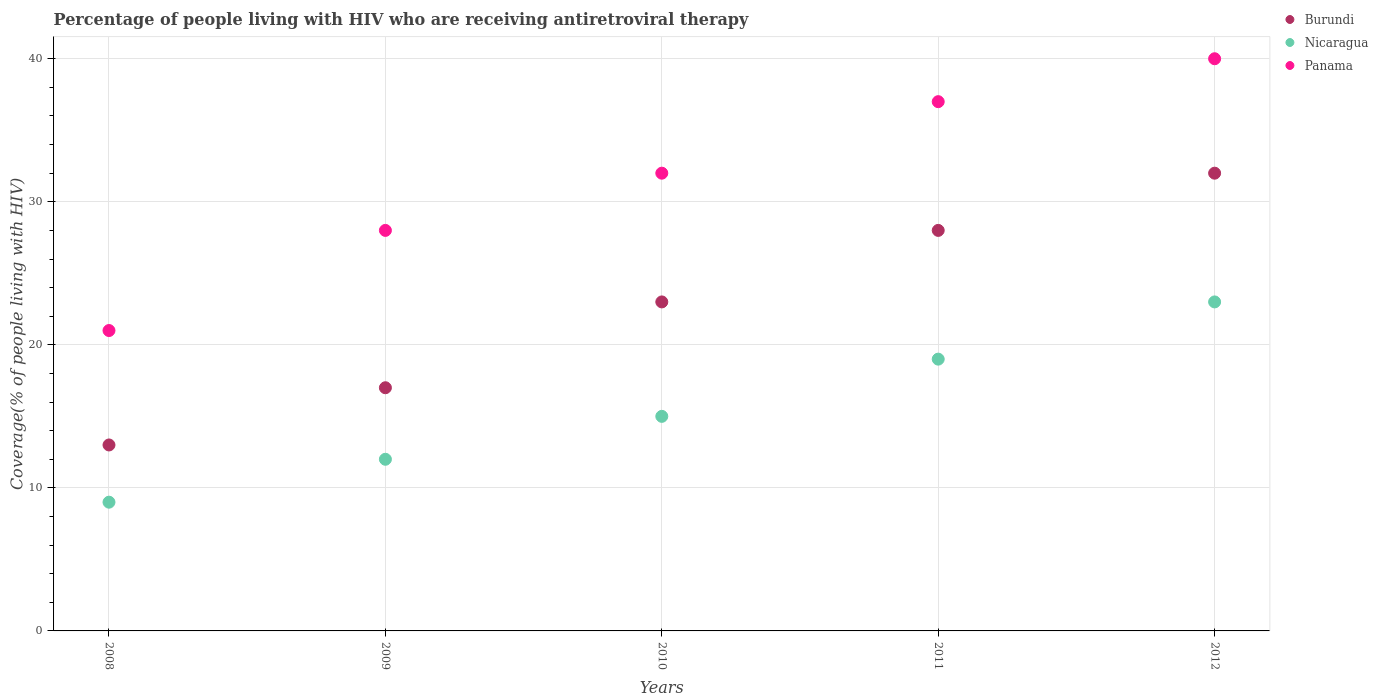What is the percentage of the HIV infected people who are receiving antiretroviral therapy in Nicaragua in 2011?
Provide a succinct answer. 19. Across all years, what is the maximum percentage of the HIV infected people who are receiving antiretroviral therapy in Burundi?
Offer a terse response. 32. Across all years, what is the minimum percentage of the HIV infected people who are receiving antiretroviral therapy in Nicaragua?
Offer a terse response. 9. In which year was the percentage of the HIV infected people who are receiving antiretroviral therapy in Panama maximum?
Provide a succinct answer. 2012. What is the total percentage of the HIV infected people who are receiving antiretroviral therapy in Burundi in the graph?
Your answer should be compact. 113. What is the difference between the percentage of the HIV infected people who are receiving antiretroviral therapy in Nicaragua in 2010 and that in 2012?
Offer a very short reply. -8. What is the difference between the percentage of the HIV infected people who are receiving antiretroviral therapy in Nicaragua in 2011 and the percentage of the HIV infected people who are receiving antiretroviral therapy in Panama in 2010?
Your response must be concise. -13. What is the average percentage of the HIV infected people who are receiving antiretroviral therapy in Nicaragua per year?
Ensure brevity in your answer.  15.6. In the year 2008, what is the difference between the percentage of the HIV infected people who are receiving antiretroviral therapy in Nicaragua and percentage of the HIV infected people who are receiving antiretroviral therapy in Panama?
Your response must be concise. -12. In how many years, is the percentage of the HIV infected people who are receiving antiretroviral therapy in Nicaragua greater than 36 %?
Your response must be concise. 0. What is the ratio of the percentage of the HIV infected people who are receiving antiretroviral therapy in Burundi in 2008 to that in 2011?
Your answer should be compact. 0.46. Is the difference between the percentage of the HIV infected people who are receiving antiretroviral therapy in Nicaragua in 2010 and 2011 greater than the difference between the percentage of the HIV infected people who are receiving antiretroviral therapy in Panama in 2010 and 2011?
Your response must be concise. Yes. What is the difference between the highest and the lowest percentage of the HIV infected people who are receiving antiretroviral therapy in Panama?
Provide a succinct answer. 19. In how many years, is the percentage of the HIV infected people who are receiving antiretroviral therapy in Nicaragua greater than the average percentage of the HIV infected people who are receiving antiretroviral therapy in Nicaragua taken over all years?
Your answer should be very brief. 2. Is the sum of the percentage of the HIV infected people who are receiving antiretroviral therapy in Panama in 2008 and 2010 greater than the maximum percentage of the HIV infected people who are receiving antiretroviral therapy in Nicaragua across all years?
Provide a short and direct response. Yes. Is it the case that in every year, the sum of the percentage of the HIV infected people who are receiving antiretroviral therapy in Burundi and percentage of the HIV infected people who are receiving antiretroviral therapy in Panama  is greater than the percentage of the HIV infected people who are receiving antiretroviral therapy in Nicaragua?
Offer a terse response. Yes. Does the percentage of the HIV infected people who are receiving antiretroviral therapy in Nicaragua monotonically increase over the years?
Give a very brief answer. Yes. How many dotlines are there?
Give a very brief answer. 3. How many years are there in the graph?
Keep it short and to the point. 5. Are the values on the major ticks of Y-axis written in scientific E-notation?
Offer a terse response. No. Where does the legend appear in the graph?
Give a very brief answer. Top right. How many legend labels are there?
Provide a succinct answer. 3. How are the legend labels stacked?
Keep it short and to the point. Vertical. What is the title of the graph?
Your response must be concise. Percentage of people living with HIV who are receiving antiretroviral therapy. Does "Bermuda" appear as one of the legend labels in the graph?
Provide a short and direct response. No. What is the label or title of the X-axis?
Give a very brief answer. Years. What is the label or title of the Y-axis?
Make the answer very short. Coverage(% of people living with HIV). What is the Coverage(% of people living with HIV) in Nicaragua in 2008?
Keep it short and to the point. 9. What is the Coverage(% of people living with HIV) in Panama in 2008?
Give a very brief answer. 21. What is the Coverage(% of people living with HIV) in Nicaragua in 2010?
Your answer should be compact. 15. What is the Coverage(% of people living with HIV) in Burundi in 2011?
Offer a very short reply. 28. What is the Coverage(% of people living with HIV) in Panama in 2011?
Your answer should be very brief. 37. What is the Coverage(% of people living with HIV) in Nicaragua in 2012?
Your response must be concise. 23. What is the Coverage(% of people living with HIV) in Panama in 2012?
Provide a short and direct response. 40. Across all years, what is the maximum Coverage(% of people living with HIV) in Nicaragua?
Ensure brevity in your answer.  23. Across all years, what is the minimum Coverage(% of people living with HIV) in Burundi?
Ensure brevity in your answer.  13. Across all years, what is the minimum Coverage(% of people living with HIV) of Nicaragua?
Provide a succinct answer. 9. Across all years, what is the minimum Coverage(% of people living with HIV) in Panama?
Offer a terse response. 21. What is the total Coverage(% of people living with HIV) in Burundi in the graph?
Offer a terse response. 113. What is the total Coverage(% of people living with HIV) of Nicaragua in the graph?
Your answer should be very brief. 78. What is the total Coverage(% of people living with HIV) of Panama in the graph?
Your response must be concise. 158. What is the difference between the Coverage(% of people living with HIV) in Burundi in 2008 and that in 2009?
Keep it short and to the point. -4. What is the difference between the Coverage(% of people living with HIV) in Nicaragua in 2008 and that in 2009?
Ensure brevity in your answer.  -3. What is the difference between the Coverage(% of people living with HIV) in Panama in 2008 and that in 2010?
Offer a terse response. -11. What is the difference between the Coverage(% of people living with HIV) of Nicaragua in 2008 and that in 2011?
Ensure brevity in your answer.  -10. What is the difference between the Coverage(% of people living with HIV) of Nicaragua in 2008 and that in 2012?
Your response must be concise. -14. What is the difference between the Coverage(% of people living with HIV) in Burundi in 2009 and that in 2010?
Your answer should be compact. -6. What is the difference between the Coverage(% of people living with HIV) of Burundi in 2009 and that in 2011?
Ensure brevity in your answer.  -11. What is the difference between the Coverage(% of people living with HIV) of Panama in 2009 and that in 2011?
Provide a short and direct response. -9. What is the difference between the Coverage(% of people living with HIV) of Nicaragua in 2009 and that in 2012?
Give a very brief answer. -11. What is the difference between the Coverage(% of people living with HIV) in Burundi in 2010 and that in 2011?
Your answer should be compact. -5. What is the difference between the Coverage(% of people living with HIV) of Burundi in 2010 and that in 2012?
Your answer should be compact. -9. What is the difference between the Coverage(% of people living with HIV) of Panama in 2010 and that in 2012?
Give a very brief answer. -8. What is the difference between the Coverage(% of people living with HIV) of Nicaragua in 2011 and that in 2012?
Provide a succinct answer. -4. What is the difference between the Coverage(% of people living with HIV) of Burundi in 2008 and the Coverage(% of people living with HIV) of Nicaragua in 2009?
Your answer should be compact. 1. What is the difference between the Coverage(% of people living with HIV) in Burundi in 2008 and the Coverage(% of people living with HIV) in Panama in 2009?
Your response must be concise. -15. What is the difference between the Coverage(% of people living with HIV) of Burundi in 2008 and the Coverage(% of people living with HIV) of Nicaragua in 2010?
Keep it short and to the point. -2. What is the difference between the Coverage(% of people living with HIV) of Burundi in 2008 and the Coverage(% of people living with HIV) of Panama in 2010?
Offer a very short reply. -19. What is the difference between the Coverage(% of people living with HIV) of Burundi in 2008 and the Coverage(% of people living with HIV) of Nicaragua in 2012?
Provide a short and direct response. -10. What is the difference between the Coverage(% of people living with HIV) of Nicaragua in 2008 and the Coverage(% of people living with HIV) of Panama in 2012?
Your answer should be very brief. -31. What is the difference between the Coverage(% of people living with HIV) in Burundi in 2009 and the Coverage(% of people living with HIV) in Panama in 2010?
Your answer should be compact. -15. What is the difference between the Coverage(% of people living with HIV) in Burundi in 2010 and the Coverage(% of people living with HIV) in Nicaragua in 2011?
Provide a succinct answer. 4. What is the difference between the Coverage(% of people living with HIV) in Nicaragua in 2010 and the Coverage(% of people living with HIV) in Panama in 2011?
Your answer should be very brief. -22. What is the difference between the Coverage(% of people living with HIV) in Burundi in 2010 and the Coverage(% of people living with HIV) in Panama in 2012?
Provide a succinct answer. -17. What is the difference between the Coverage(% of people living with HIV) in Burundi in 2011 and the Coverage(% of people living with HIV) in Panama in 2012?
Provide a succinct answer. -12. What is the average Coverage(% of people living with HIV) of Burundi per year?
Offer a very short reply. 22.6. What is the average Coverage(% of people living with HIV) in Nicaragua per year?
Your response must be concise. 15.6. What is the average Coverage(% of people living with HIV) in Panama per year?
Offer a very short reply. 31.6. In the year 2008, what is the difference between the Coverage(% of people living with HIV) in Burundi and Coverage(% of people living with HIV) in Nicaragua?
Offer a very short reply. 4. In the year 2008, what is the difference between the Coverage(% of people living with HIV) in Nicaragua and Coverage(% of people living with HIV) in Panama?
Offer a very short reply. -12. In the year 2009, what is the difference between the Coverage(% of people living with HIV) in Burundi and Coverage(% of people living with HIV) in Panama?
Ensure brevity in your answer.  -11. In the year 2009, what is the difference between the Coverage(% of people living with HIV) in Nicaragua and Coverage(% of people living with HIV) in Panama?
Offer a terse response. -16. In the year 2011, what is the difference between the Coverage(% of people living with HIV) of Burundi and Coverage(% of people living with HIV) of Nicaragua?
Ensure brevity in your answer.  9. In the year 2011, what is the difference between the Coverage(% of people living with HIV) in Burundi and Coverage(% of people living with HIV) in Panama?
Ensure brevity in your answer.  -9. In the year 2012, what is the difference between the Coverage(% of people living with HIV) in Burundi and Coverage(% of people living with HIV) in Nicaragua?
Your response must be concise. 9. In the year 2012, what is the difference between the Coverage(% of people living with HIV) of Burundi and Coverage(% of people living with HIV) of Panama?
Make the answer very short. -8. What is the ratio of the Coverage(% of people living with HIV) of Burundi in 2008 to that in 2009?
Your answer should be very brief. 0.76. What is the ratio of the Coverage(% of people living with HIV) in Burundi in 2008 to that in 2010?
Provide a short and direct response. 0.57. What is the ratio of the Coverage(% of people living with HIV) in Nicaragua in 2008 to that in 2010?
Your response must be concise. 0.6. What is the ratio of the Coverage(% of people living with HIV) of Panama in 2008 to that in 2010?
Give a very brief answer. 0.66. What is the ratio of the Coverage(% of people living with HIV) in Burundi in 2008 to that in 2011?
Offer a terse response. 0.46. What is the ratio of the Coverage(% of people living with HIV) of Nicaragua in 2008 to that in 2011?
Ensure brevity in your answer.  0.47. What is the ratio of the Coverage(% of people living with HIV) in Panama in 2008 to that in 2011?
Give a very brief answer. 0.57. What is the ratio of the Coverage(% of people living with HIV) in Burundi in 2008 to that in 2012?
Offer a very short reply. 0.41. What is the ratio of the Coverage(% of people living with HIV) in Nicaragua in 2008 to that in 2012?
Provide a short and direct response. 0.39. What is the ratio of the Coverage(% of people living with HIV) of Panama in 2008 to that in 2012?
Provide a short and direct response. 0.53. What is the ratio of the Coverage(% of people living with HIV) in Burundi in 2009 to that in 2010?
Give a very brief answer. 0.74. What is the ratio of the Coverage(% of people living with HIV) in Panama in 2009 to that in 2010?
Keep it short and to the point. 0.88. What is the ratio of the Coverage(% of people living with HIV) in Burundi in 2009 to that in 2011?
Keep it short and to the point. 0.61. What is the ratio of the Coverage(% of people living with HIV) in Nicaragua in 2009 to that in 2011?
Ensure brevity in your answer.  0.63. What is the ratio of the Coverage(% of people living with HIV) of Panama in 2009 to that in 2011?
Ensure brevity in your answer.  0.76. What is the ratio of the Coverage(% of people living with HIV) of Burundi in 2009 to that in 2012?
Your response must be concise. 0.53. What is the ratio of the Coverage(% of people living with HIV) of Nicaragua in 2009 to that in 2012?
Your response must be concise. 0.52. What is the ratio of the Coverage(% of people living with HIV) in Panama in 2009 to that in 2012?
Make the answer very short. 0.7. What is the ratio of the Coverage(% of people living with HIV) in Burundi in 2010 to that in 2011?
Your answer should be compact. 0.82. What is the ratio of the Coverage(% of people living with HIV) of Nicaragua in 2010 to that in 2011?
Offer a very short reply. 0.79. What is the ratio of the Coverage(% of people living with HIV) of Panama in 2010 to that in 2011?
Keep it short and to the point. 0.86. What is the ratio of the Coverage(% of people living with HIV) of Burundi in 2010 to that in 2012?
Offer a terse response. 0.72. What is the ratio of the Coverage(% of people living with HIV) in Nicaragua in 2010 to that in 2012?
Offer a terse response. 0.65. What is the ratio of the Coverage(% of people living with HIV) of Nicaragua in 2011 to that in 2012?
Your answer should be very brief. 0.83. What is the ratio of the Coverage(% of people living with HIV) of Panama in 2011 to that in 2012?
Ensure brevity in your answer.  0.93. What is the difference between the highest and the second highest Coverage(% of people living with HIV) in Nicaragua?
Provide a succinct answer. 4. What is the difference between the highest and the second highest Coverage(% of people living with HIV) of Panama?
Give a very brief answer. 3. What is the difference between the highest and the lowest Coverage(% of people living with HIV) in Burundi?
Provide a succinct answer. 19. What is the difference between the highest and the lowest Coverage(% of people living with HIV) of Panama?
Give a very brief answer. 19. 